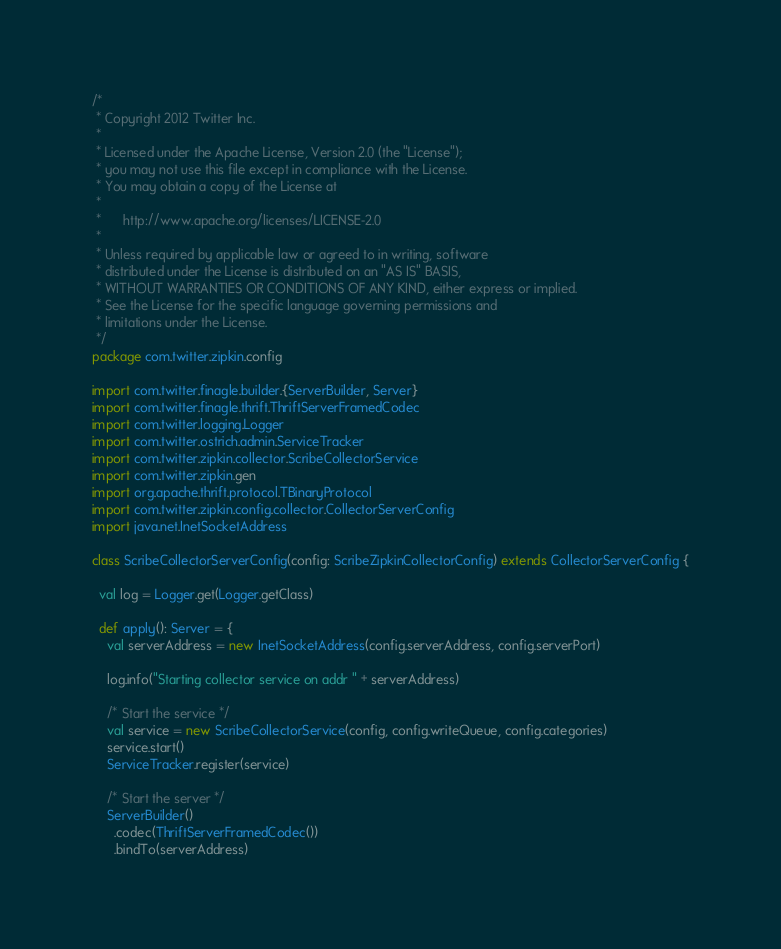<code> <loc_0><loc_0><loc_500><loc_500><_Scala_>/*
 * Copyright 2012 Twitter Inc.
 *
 * Licensed under the Apache License, Version 2.0 (the "License");
 * you may not use this file except in compliance with the License.
 * You may obtain a copy of the License at
 *
 *      http://www.apache.org/licenses/LICENSE-2.0
 *
 * Unless required by applicable law or agreed to in writing, software
 * distributed under the License is distributed on an "AS IS" BASIS,
 * WITHOUT WARRANTIES OR CONDITIONS OF ANY KIND, either express or implied.
 * See the License for the specific language governing permissions and
 * limitations under the License.
 */
package com.twitter.zipkin.config

import com.twitter.finagle.builder.{ServerBuilder, Server}
import com.twitter.finagle.thrift.ThriftServerFramedCodec
import com.twitter.logging.Logger
import com.twitter.ostrich.admin.ServiceTracker
import com.twitter.zipkin.collector.ScribeCollectorService
import com.twitter.zipkin.gen
import org.apache.thrift.protocol.TBinaryProtocol
import com.twitter.zipkin.config.collector.CollectorServerConfig
import java.net.InetSocketAddress

class ScribeCollectorServerConfig(config: ScribeZipkinCollectorConfig) extends CollectorServerConfig {

  val log = Logger.get(Logger.getClass)

  def apply(): Server = {
    val serverAddress = new InetSocketAddress(config.serverAddress, config.serverPort)

    log.info("Starting collector service on addr " + serverAddress)

    /* Start the service */
    val service = new ScribeCollectorService(config, config.writeQueue, config.categories)
    service.start()
    ServiceTracker.register(service)

    /* Start the server */
    ServerBuilder()
      .codec(ThriftServerFramedCodec())
      .bindTo(serverAddress)</code> 